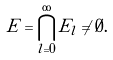Convert formula to latex. <formula><loc_0><loc_0><loc_500><loc_500>E = \bigcap _ { l = 0 } ^ { \infty } E _ { l } \ne \emptyset .</formula> 